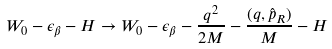Convert formula to latex. <formula><loc_0><loc_0><loc_500><loc_500>W _ { 0 } - \epsilon _ { \beta } - H \rightarrow W _ { 0 } - \epsilon _ { \beta } - \frac { q ^ { 2 } } { 2 M } - \frac { ( { q } , { \hat { p } } _ { R } ) } { M } - H</formula> 